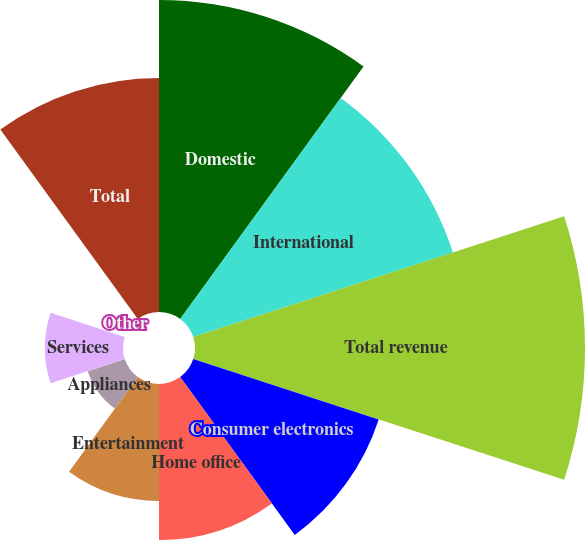<chart> <loc_0><loc_0><loc_500><loc_500><pie_chart><fcel>Domestic<fcel>International<fcel>Total revenue<fcel>Consumer electronics<fcel>Home office<fcel>Entertainment<fcel>Appliances<fcel>Services<fcel>Other<fcel>Total<nl><fcel>17.39%<fcel>15.22%<fcel>21.74%<fcel>10.87%<fcel>8.7%<fcel>6.52%<fcel>2.17%<fcel>4.35%<fcel>0.0%<fcel>13.04%<nl></chart> 